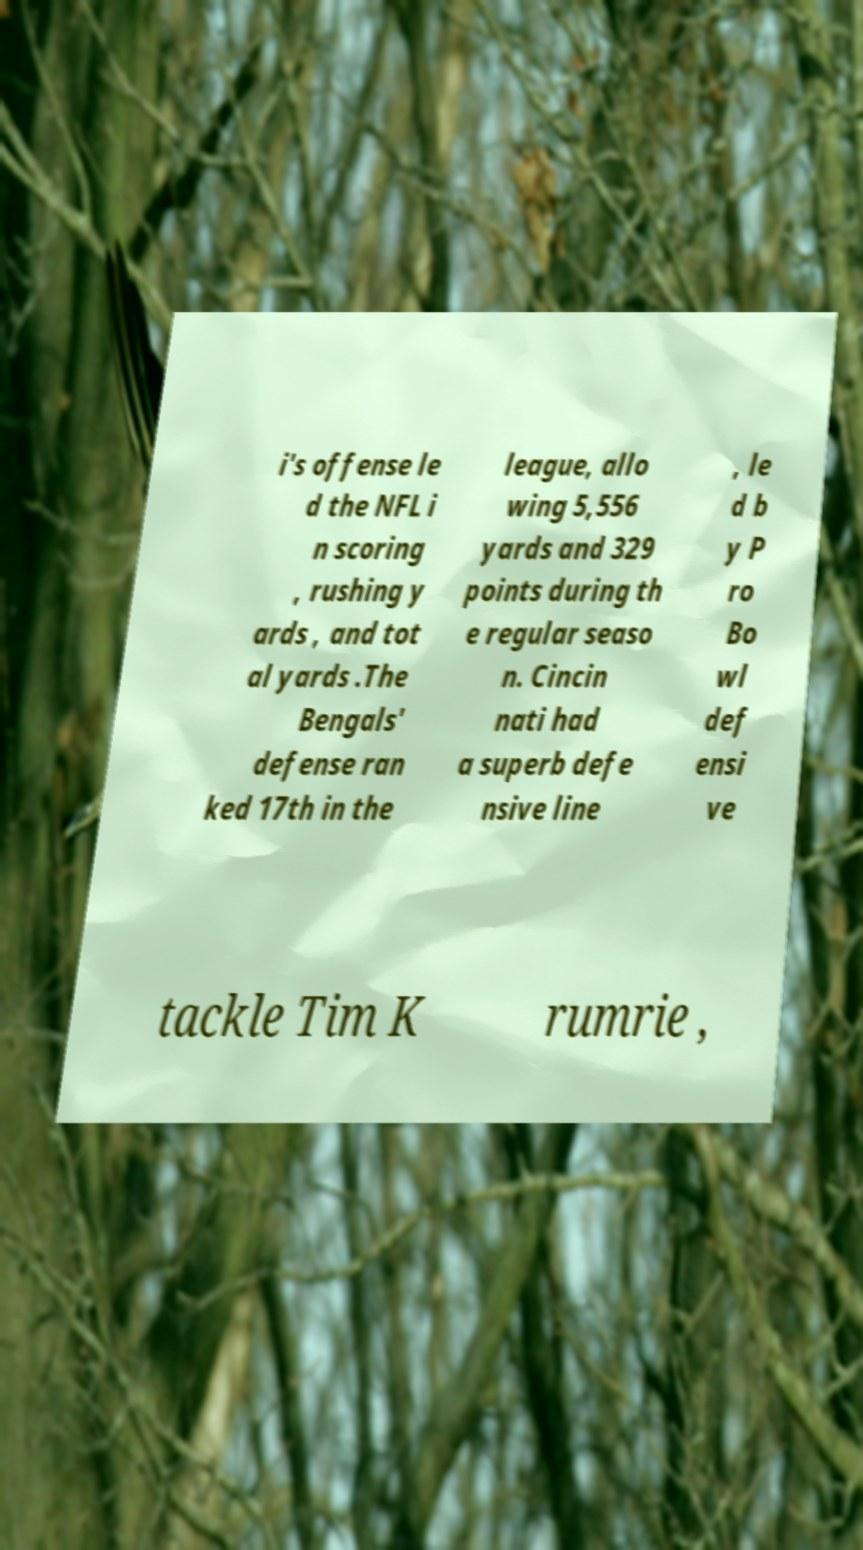Could you assist in decoding the text presented in this image and type it out clearly? i's offense le d the NFL i n scoring , rushing y ards , and tot al yards .The Bengals' defense ran ked 17th in the league, allo wing 5,556 yards and 329 points during th e regular seaso n. Cincin nati had a superb defe nsive line , le d b y P ro Bo wl def ensi ve tackle Tim K rumrie , 